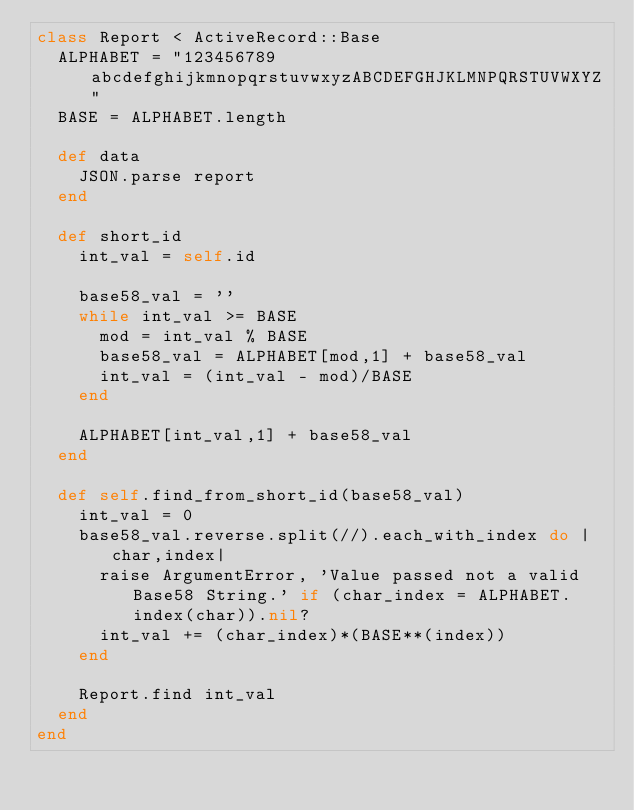Convert code to text. <code><loc_0><loc_0><loc_500><loc_500><_Ruby_>class Report < ActiveRecord::Base
  ALPHABET = "123456789abcdefghijkmnopqrstuvwxyzABCDEFGHJKLMNPQRSTUVWXYZ"
  BASE = ALPHABET.length

  def data
    JSON.parse report
  end

  def short_id
    int_val = self.id

    base58_val = ''
    while int_val >= BASE
      mod = int_val % BASE
      base58_val = ALPHABET[mod,1] + base58_val
      int_val = (int_val - mod)/BASE
    end

    ALPHABET[int_val,1] + base58_val
  end

  def self.find_from_short_id(base58_val)
    int_val = 0
    base58_val.reverse.split(//).each_with_index do |char,index|
      raise ArgumentError, 'Value passed not a valid Base58 String.' if (char_index = ALPHABET.index(char)).nil?
      int_val += (char_index)*(BASE**(index))
    end

    Report.find int_val
  end
end
</code> 